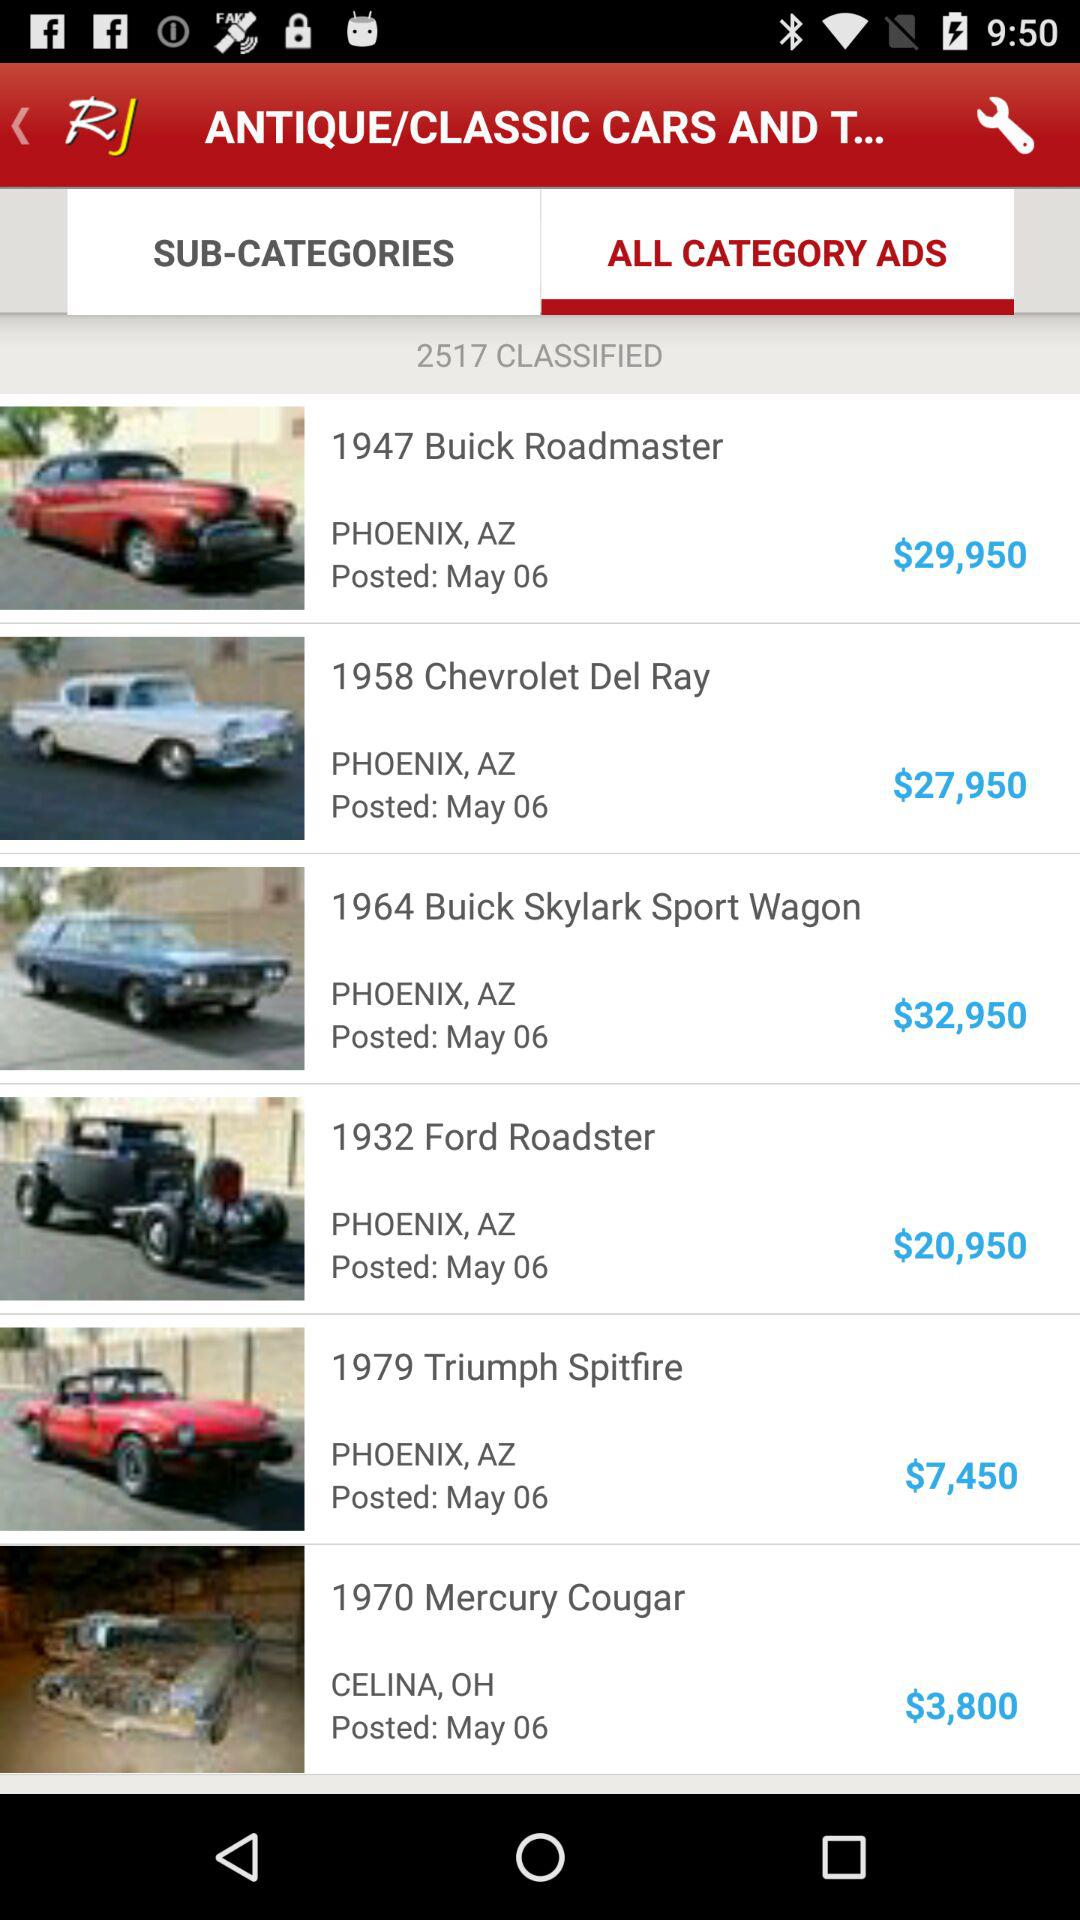What is the price of a "Mercury Cougar"? The price of a "Mercury Cougar" is $3,800. 